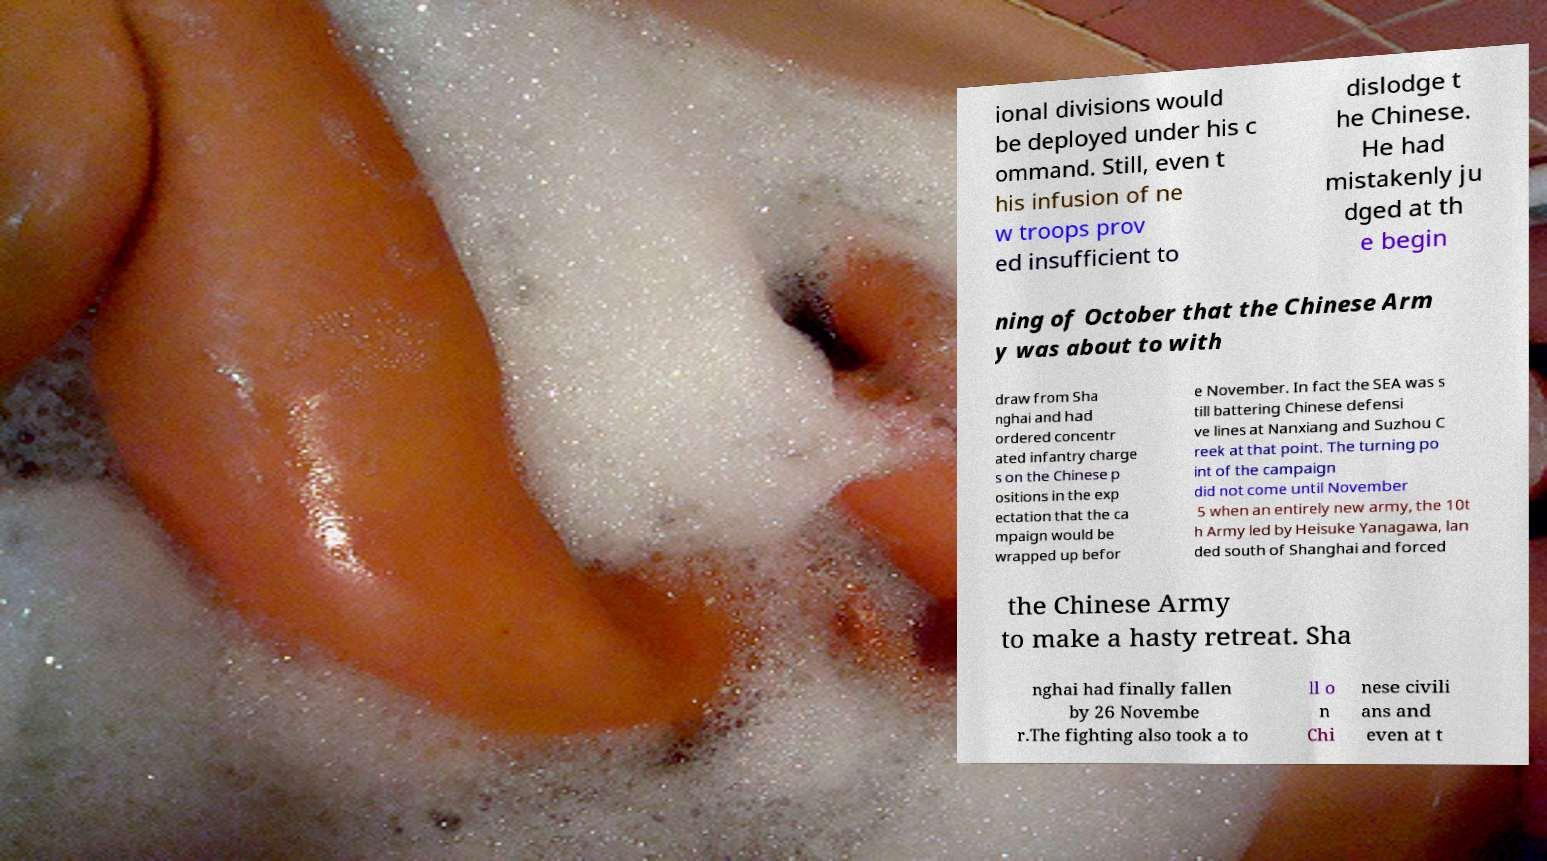Please identify and transcribe the text found in this image. ional divisions would be deployed under his c ommand. Still, even t his infusion of ne w troops prov ed insufficient to dislodge t he Chinese. He had mistakenly ju dged at th e begin ning of October that the Chinese Arm y was about to with draw from Sha nghai and had ordered concentr ated infantry charge s on the Chinese p ositions in the exp ectation that the ca mpaign would be wrapped up befor e November. In fact the SEA was s till battering Chinese defensi ve lines at Nanxiang and Suzhou C reek at that point. The turning po int of the campaign did not come until November 5 when an entirely new army, the 10t h Army led by Heisuke Yanagawa, lan ded south of Shanghai and forced the Chinese Army to make a hasty retreat. Sha nghai had finally fallen by 26 Novembe r.The fighting also took a to ll o n Chi nese civili ans and even at t 